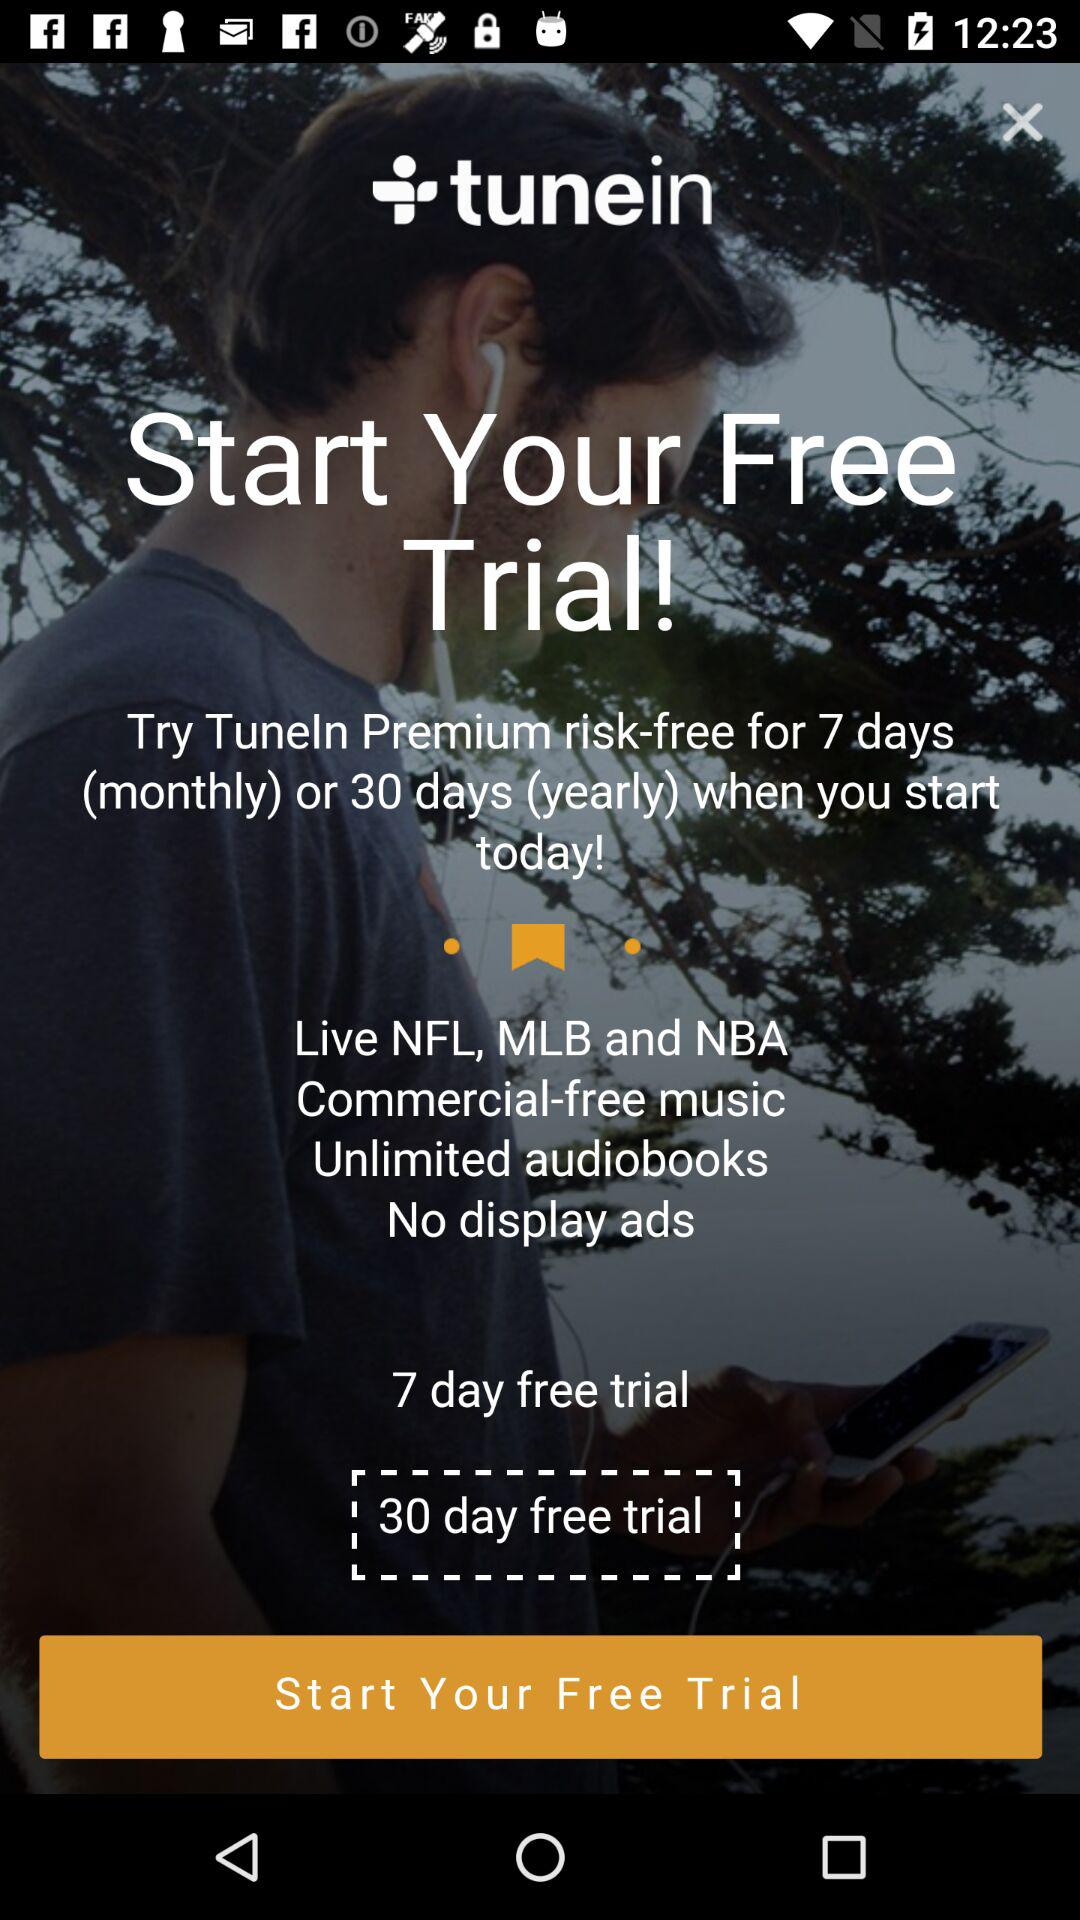Who is this application powered by?
When the provided information is insufficient, respond with <no answer>. <no answer> 